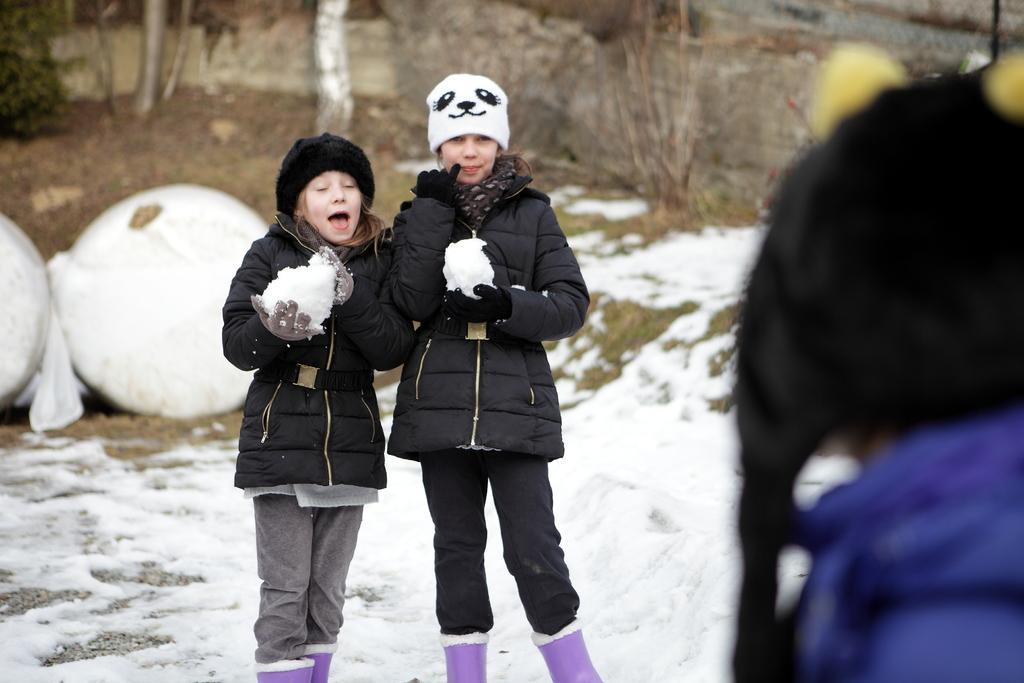Can you describe this image briefly? In this image we can see three people and among them two people are standing and holding snow and we can see snow on the ground. There are some trees in the background. 